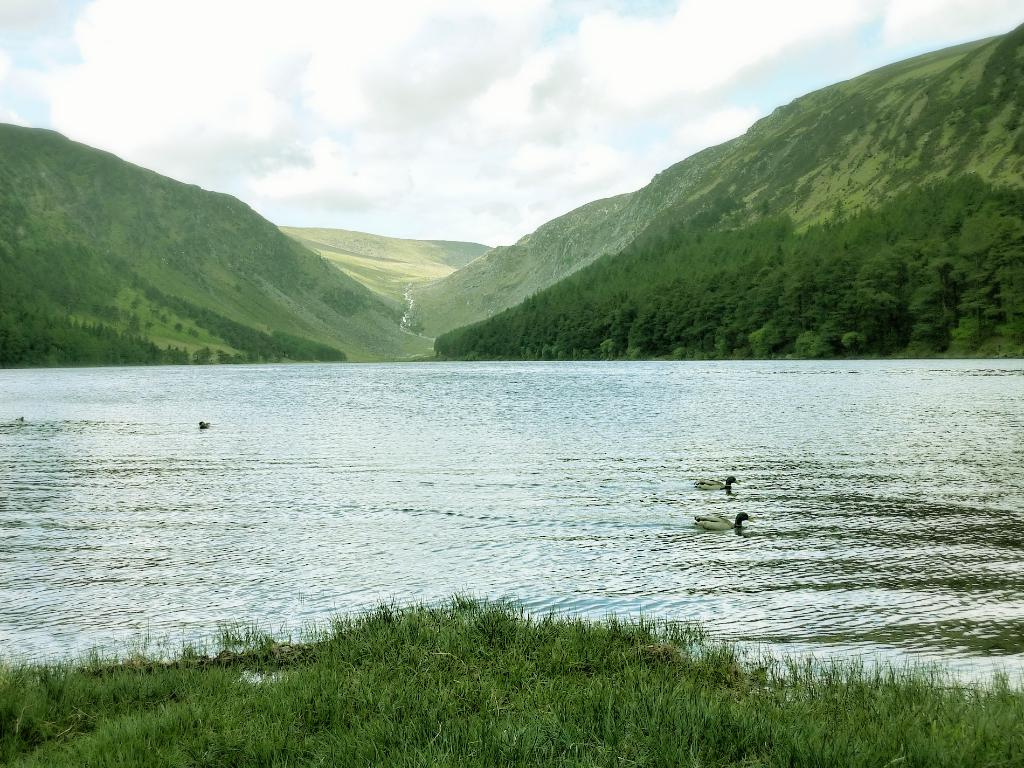What type of animals can be seen in the image? There are ducks in the water in the image. What type of vegetation is visible in the image? There is grass and trees visible in the image. What can be seen in the background of the image? There are hills and the sky visible in the background. Are there any fairies flying spades in the image? There are no flying spades present in the image. 